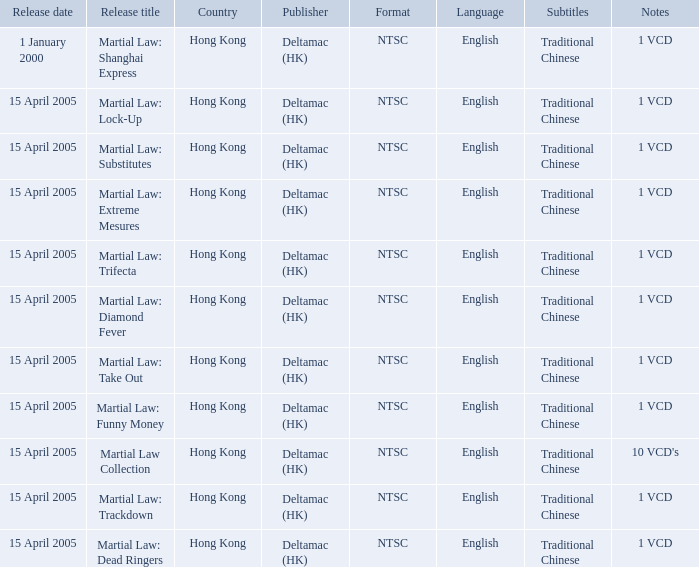What is the release date of Martial Law: Take Out? 15 April 2005. 